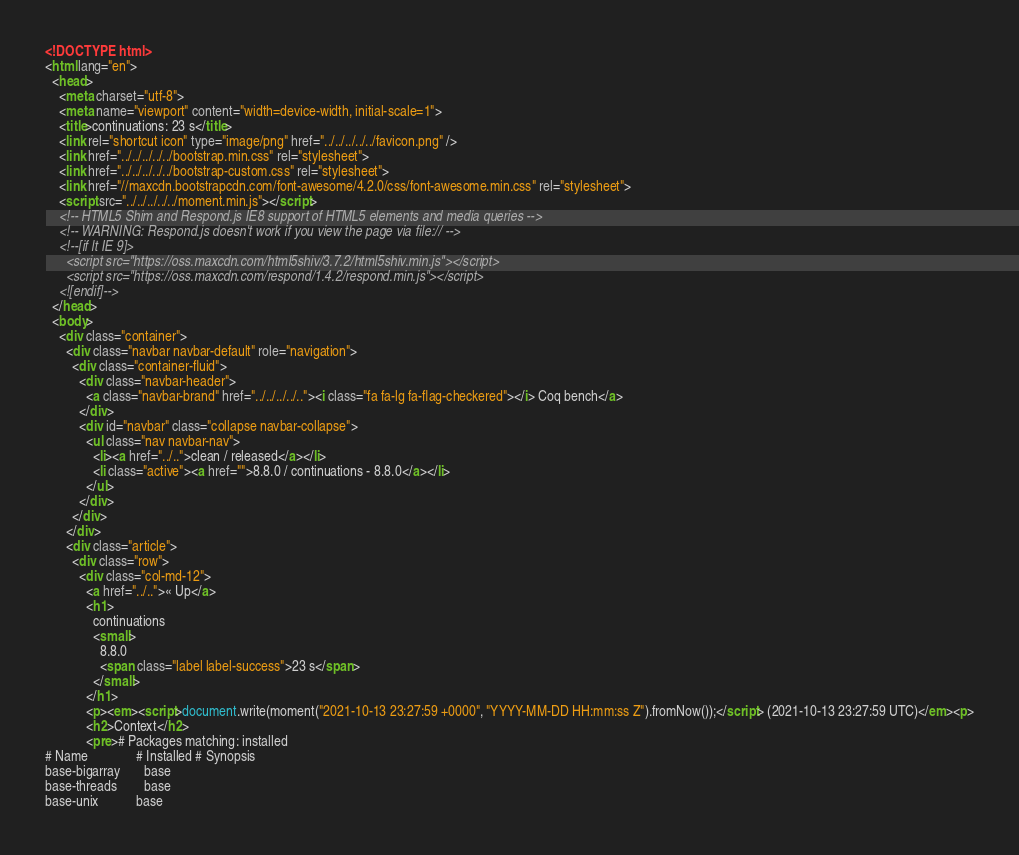Convert code to text. <code><loc_0><loc_0><loc_500><loc_500><_HTML_><!DOCTYPE html>
<html lang="en">
  <head>
    <meta charset="utf-8">
    <meta name="viewport" content="width=device-width, initial-scale=1">
    <title>continuations: 23 s</title>
    <link rel="shortcut icon" type="image/png" href="../../../../../favicon.png" />
    <link href="../../../../../bootstrap.min.css" rel="stylesheet">
    <link href="../../../../../bootstrap-custom.css" rel="stylesheet">
    <link href="//maxcdn.bootstrapcdn.com/font-awesome/4.2.0/css/font-awesome.min.css" rel="stylesheet">
    <script src="../../../../../moment.min.js"></script>
    <!-- HTML5 Shim and Respond.js IE8 support of HTML5 elements and media queries -->
    <!-- WARNING: Respond.js doesn't work if you view the page via file:// -->
    <!--[if lt IE 9]>
      <script src="https://oss.maxcdn.com/html5shiv/3.7.2/html5shiv.min.js"></script>
      <script src="https://oss.maxcdn.com/respond/1.4.2/respond.min.js"></script>
    <![endif]-->
  </head>
  <body>
    <div class="container">
      <div class="navbar navbar-default" role="navigation">
        <div class="container-fluid">
          <div class="navbar-header">
            <a class="navbar-brand" href="../../../../.."><i class="fa fa-lg fa-flag-checkered"></i> Coq bench</a>
          </div>
          <div id="navbar" class="collapse navbar-collapse">
            <ul class="nav navbar-nav">
              <li><a href="../..">clean / released</a></li>
              <li class="active"><a href="">8.8.0 / continuations - 8.8.0</a></li>
            </ul>
          </div>
        </div>
      </div>
      <div class="article">
        <div class="row">
          <div class="col-md-12">
            <a href="../..">« Up</a>
            <h1>
              continuations
              <small>
                8.8.0
                <span class="label label-success">23 s</span>
              </small>
            </h1>
            <p><em><script>document.write(moment("2021-10-13 23:27:59 +0000", "YYYY-MM-DD HH:mm:ss Z").fromNow());</script> (2021-10-13 23:27:59 UTC)</em><p>
            <h2>Context</h2>
            <pre># Packages matching: installed
# Name              # Installed # Synopsis
base-bigarray       base
base-threads        base
base-unix           base</code> 